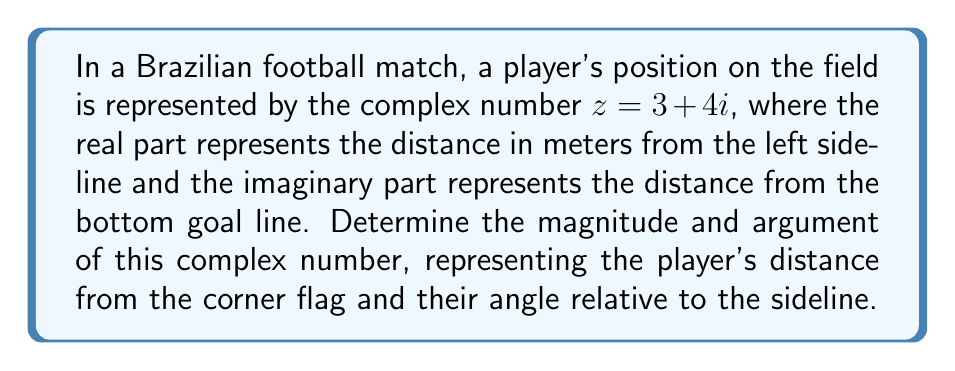Teach me how to tackle this problem. To find the magnitude and argument of the complex number $z = 3 + 4i$, we'll follow these steps:

1. Magnitude (r):
   The magnitude is given by the formula $r = \sqrt{a^2 + b^2}$, where $a$ is the real part and $b$ is the imaginary part.
   
   $$r = \sqrt{3^2 + 4^2} = \sqrt{9 + 16} = \sqrt{25} = 5$$

2. Argument (θ):
   The argument is given by the formula $\theta = \tan^{-1}(\frac{b}{a})$, where $a$ is the real part and $b$ is the imaginary part.
   
   $$\theta = \tan^{-1}(\frac{4}{3}) \approx 0.9273 \text{ radians}$$

   To convert radians to degrees:
   
   $$\theta = 0.9273 \times \frac{180°}{\pi} \approx 53.13°$$

Therefore, the player is 5 meters away from the corner flag at an angle of approximately 53.13° relative to the sideline.
Answer: Magnitude: 5 meters, Argument: 53.13° 